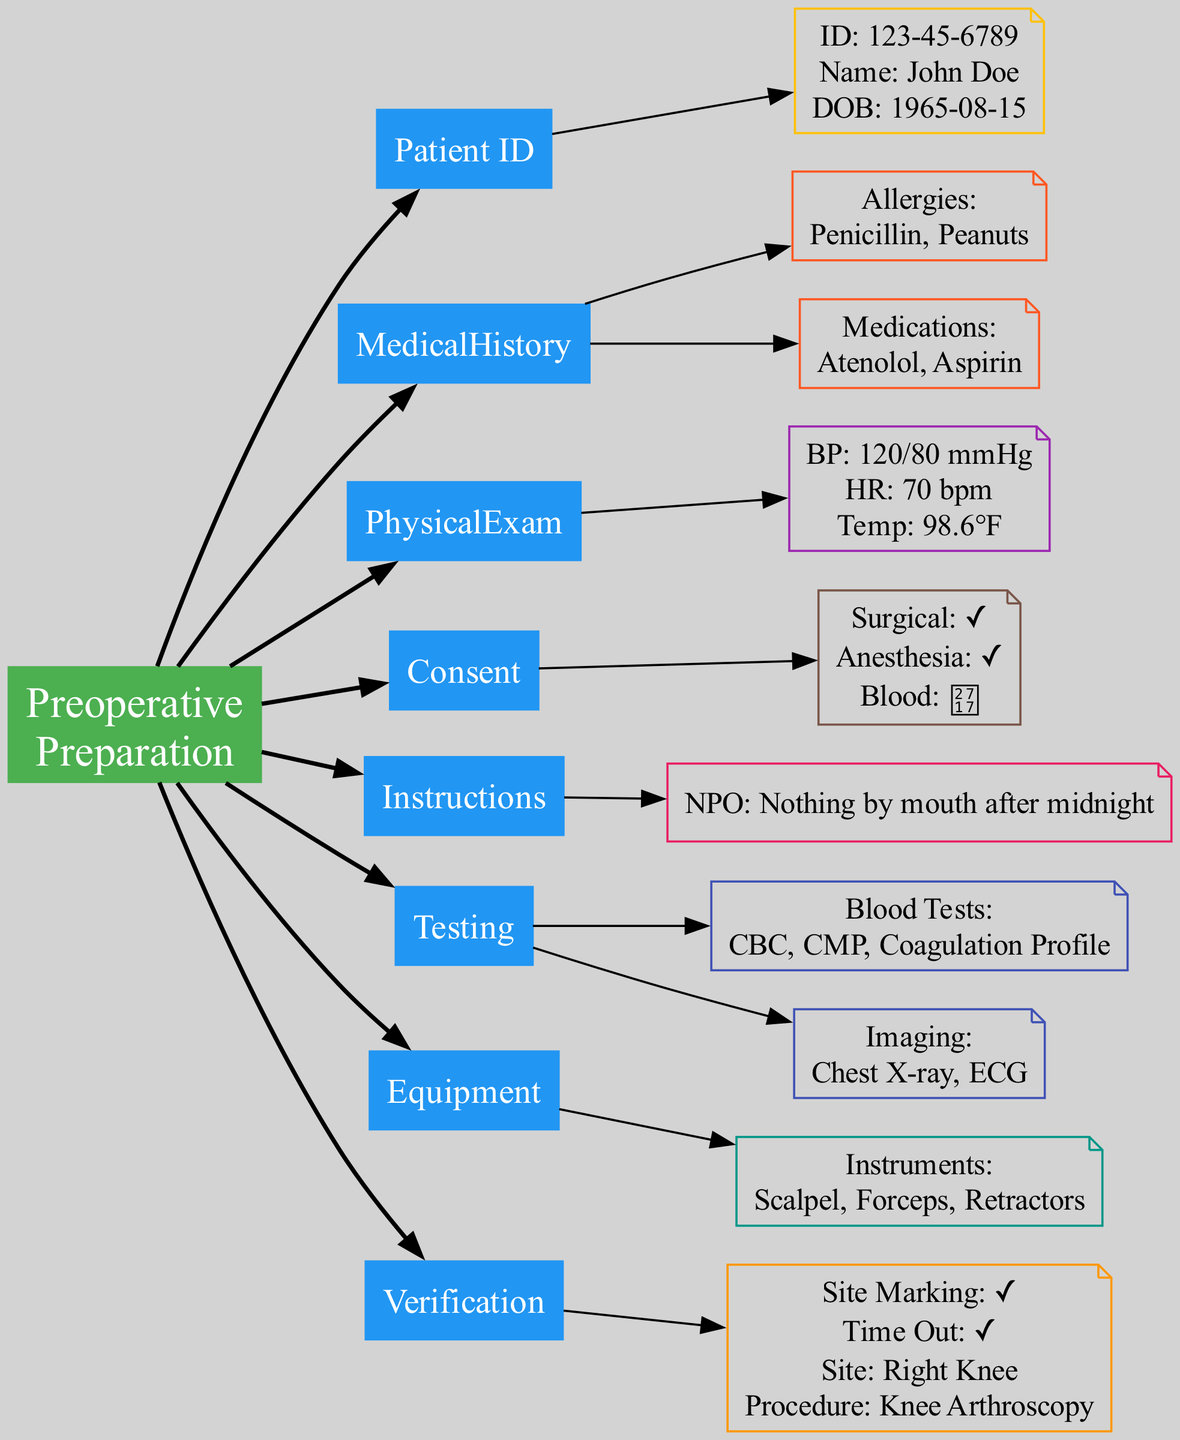What is the patient's name? The diagram includes a node for Patient Identification, which contains the patient's details, including name. From that node, the name listed is "John Doe."
Answer: John Doe How many allergies are listed in the medical history? In the Medical History Review node, there is a corresponding node for Allergies that lists "Penicillin" and "Peanuts." Counting these gives a total of 2 allergies.
Answer: 2 What is the NPO status? The Preoperative Instructions node contains an entry for the NPO status, which states "Nothing by mouth after midnight." This provides a clear directive regarding preoperative dietary restrictions.
Answer: Nothing by mouth after midnight What are the blood tests required? The Preoperative Testing node has a corresponding node that lists the required blood tests: "CBC," "CMP," and "Coagulation Profile." These tests are detailed under that node.
Answer: CBC, CMP, Coagulation Profile What is the correct surgical site? The Final Verification node explicitly mentions the correct surgical site as "Right Knee." This information verifies the site for the upcoming procedure.
Answer: Right Knee What are the surgical instruments listed? In the Equipment Preparation node, there is a note that specifies the surgical instruments needed, listed as "Scalpel," "Forceps," and "Retractors." These instruments are outlined in that section.
Answer: Scalpel, Forceps, Retractors Describe the anesthesia consent status. The Consent Forms node provides details on various consent statuses. In this case, the Anesthesia Consent is marked as true, meaning it has been obtained.
Answer: true How many nodes are dedicated to patient medical history? The Medical History Review node branches into two nodes: Allergies and Medications. Therefore, there are a total of 2 nodes related to patient medical history.
Answer: 2 Explain the preoperative hygiene instructions mentioned. The Preoperative Instructions node includes specific hygiene instructions, stating "Shower with antiseptic soap night before" and "Remove nail polish." These instructions are clear requirements to ensure patient cleanliness.
Answer: Shower with antiseptic soap night before, Remove nail polish 